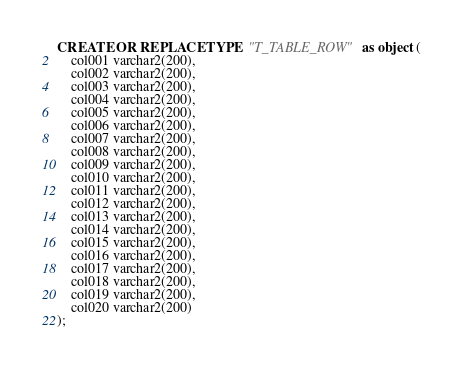<code> <loc_0><loc_0><loc_500><loc_500><_SQL_>CREATE OR REPLACE TYPE  "T_TABLE_ROW" as object (
    col001 varchar2(200),
    col002 varchar2(200),
    col003 varchar2(200),
    col004 varchar2(200),
    col005 varchar2(200),
    col006 varchar2(200),
    col007 varchar2(200),
    col008 varchar2(200),
    col009 varchar2(200),
    col010 varchar2(200),
    col011 varchar2(200),
    col012 varchar2(200),
    col013 varchar2(200),
    col014 varchar2(200),
    col015 varchar2(200),
    col016 varchar2(200),
    col017 varchar2(200),
    col018 varchar2(200),
    col019 varchar2(200),
    col020 varchar2(200)
);
</code> 